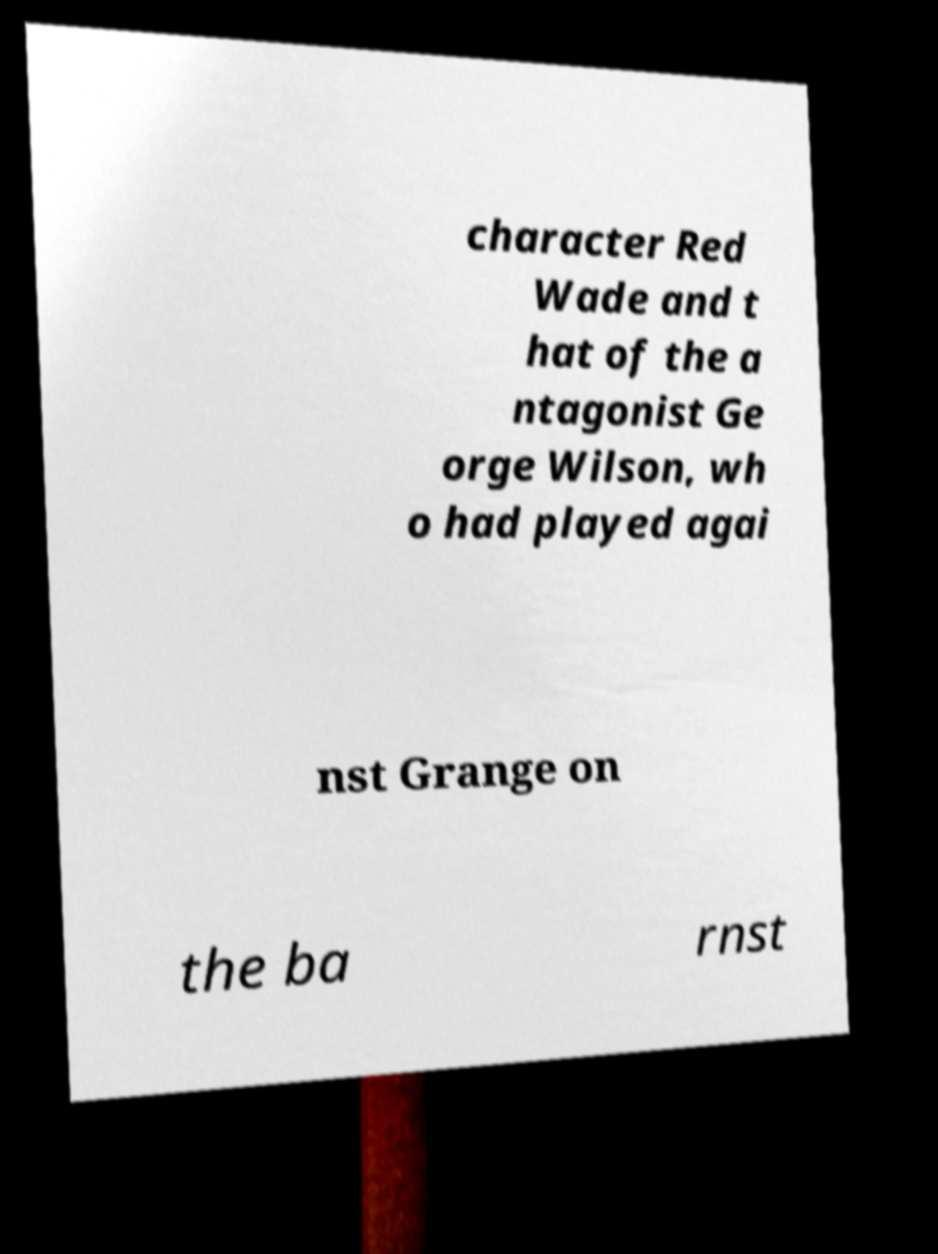Please identify and transcribe the text found in this image. character Red Wade and t hat of the a ntagonist Ge orge Wilson, wh o had played agai nst Grange on the ba rnst 